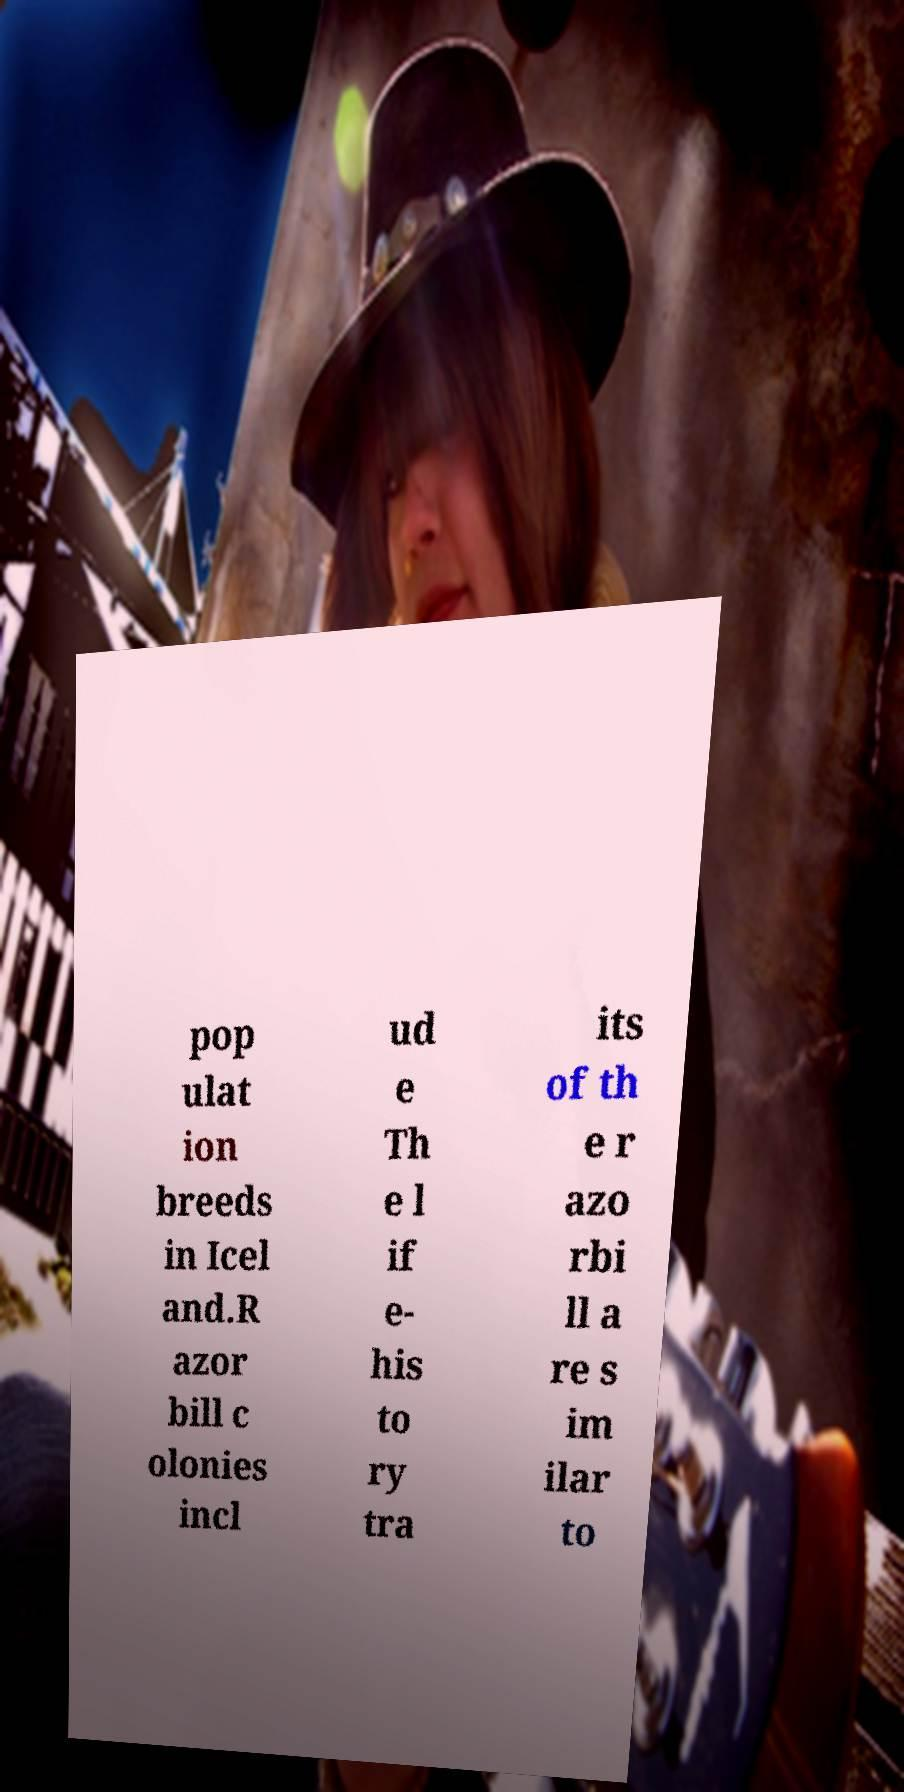Please read and relay the text visible in this image. What does it say? pop ulat ion breeds in Icel and.R azor bill c olonies incl ud e Th e l if e- his to ry tra its of th e r azo rbi ll a re s im ilar to 